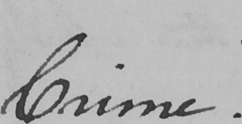Transcribe the text shown in this historical manuscript line. Crime . 